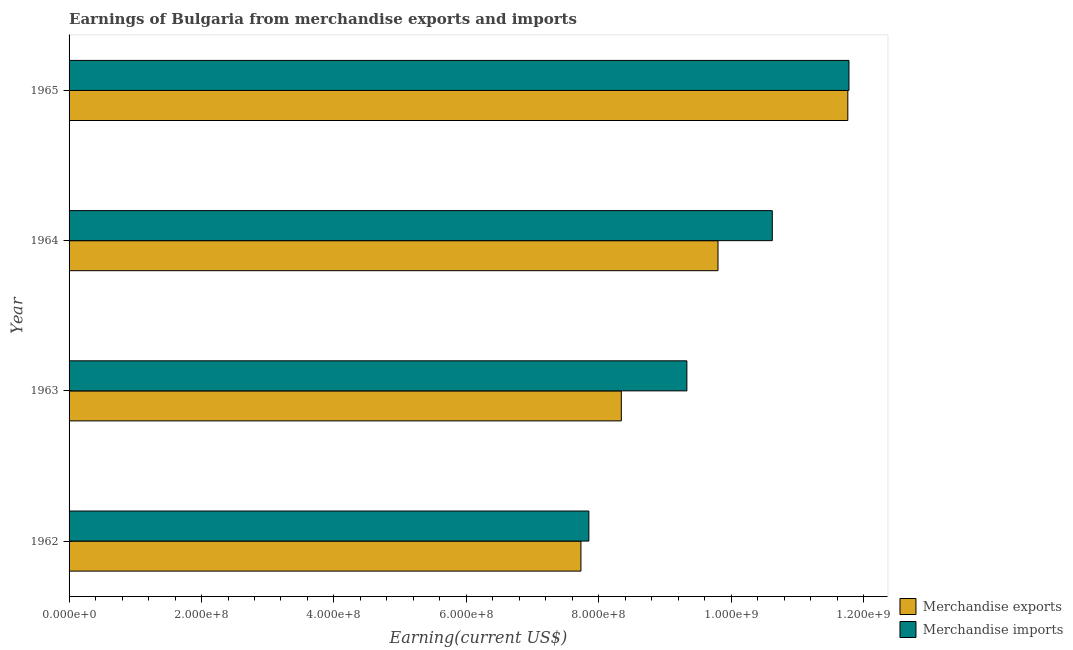How many different coloured bars are there?
Make the answer very short. 2. How many groups of bars are there?
Ensure brevity in your answer.  4. Are the number of bars per tick equal to the number of legend labels?
Your answer should be very brief. Yes. How many bars are there on the 2nd tick from the bottom?
Provide a succinct answer. 2. What is the earnings from merchandise imports in 1965?
Your answer should be very brief. 1.18e+09. Across all years, what is the maximum earnings from merchandise imports?
Give a very brief answer. 1.18e+09. Across all years, what is the minimum earnings from merchandise exports?
Offer a terse response. 7.73e+08. In which year was the earnings from merchandise imports maximum?
Ensure brevity in your answer.  1965. In which year was the earnings from merchandise imports minimum?
Your response must be concise. 1962. What is the total earnings from merchandise exports in the graph?
Ensure brevity in your answer.  3.76e+09. What is the difference between the earnings from merchandise exports in 1962 and that in 1963?
Keep it short and to the point. -6.10e+07. What is the difference between the earnings from merchandise imports in 1964 and the earnings from merchandise exports in 1963?
Ensure brevity in your answer.  2.28e+08. What is the average earnings from merchandise exports per year?
Make the answer very short. 9.41e+08. In the year 1965, what is the difference between the earnings from merchandise imports and earnings from merchandise exports?
Make the answer very short. 1.71e+06. What is the ratio of the earnings from merchandise exports in 1962 to that in 1963?
Offer a terse response. 0.93. Is the difference between the earnings from merchandise imports in 1962 and 1963 greater than the difference between the earnings from merchandise exports in 1962 and 1963?
Keep it short and to the point. No. What is the difference between the highest and the second highest earnings from merchandise exports?
Make the answer very short. 1.96e+08. What is the difference between the highest and the lowest earnings from merchandise exports?
Ensure brevity in your answer.  4.03e+08. In how many years, is the earnings from merchandise exports greater than the average earnings from merchandise exports taken over all years?
Give a very brief answer. 2. What does the 1st bar from the bottom in 1964 represents?
Give a very brief answer. Merchandise exports. How many bars are there?
Offer a terse response. 8. Are all the bars in the graph horizontal?
Give a very brief answer. Yes. How many years are there in the graph?
Offer a terse response. 4. Does the graph contain any zero values?
Your answer should be compact. No. Where does the legend appear in the graph?
Your response must be concise. Bottom right. How many legend labels are there?
Provide a short and direct response. 2. What is the title of the graph?
Ensure brevity in your answer.  Earnings of Bulgaria from merchandise exports and imports. Does "Researchers" appear as one of the legend labels in the graph?
Your answer should be compact. No. What is the label or title of the X-axis?
Your answer should be compact. Earning(current US$). What is the Earning(current US$) of Merchandise exports in 1962?
Offer a very short reply. 7.73e+08. What is the Earning(current US$) in Merchandise imports in 1962?
Ensure brevity in your answer.  7.85e+08. What is the Earning(current US$) in Merchandise exports in 1963?
Ensure brevity in your answer.  8.34e+08. What is the Earning(current US$) of Merchandise imports in 1963?
Make the answer very short. 9.33e+08. What is the Earning(current US$) of Merchandise exports in 1964?
Provide a short and direct response. 9.80e+08. What is the Earning(current US$) in Merchandise imports in 1964?
Give a very brief answer. 1.06e+09. What is the Earning(current US$) of Merchandise exports in 1965?
Your answer should be compact. 1.18e+09. What is the Earning(current US$) of Merchandise imports in 1965?
Provide a short and direct response. 1.18e+09. Across all years, what is the maximum Earning(current US$) in Merchandise exports?
Keep it short and to the point. 1.18e+09. Across all years, what is the maximum Earning(current US$) in Merchandise imports?
Make the answer very short. 1.18e+09. Across all years, what is the minimum Earning(current US$) of Merchandise exports?
Offer a very short reply. 7.73e+08. Across all years, what is the minimum Earning(current US$) of Merchandise imports?
Ensure brevity in your answer.  7.85e+08. What is the total Earning(current US$) in Merchandise exports in the graph?
Your response must be concise. 3.76e+09. What is the total Earning(current US$) in Merchandise imports in the graph?
Your answer should be very brief. 3.96e+09. What is the difference between the Earning(current US$) in Merchandise exports in 1962 and that in 1963?
Keep it short and to the point. -6.10e+07. What is the difference between the Earning(current US$) of Merchandise imports in 1962 and that in 1963?
Keep it short and to the point. -1.48e+08. What is the difference between the Earning(current US$) in Merchandise exports in 1962 and that in 1964?
Your response must be concise. -2.07e+08. What is the difference between the Earning(current US$) in Merchandise imports in 1962 and that in 1964?
Your answer should be compact. -2.77e+08. What is the difference between the Earning(current US$) of Merchandise exports in 1962 and that in 1965?
Ensure brevity in your answer.  -4.03e+08. What is the difference between the Earning(current US$) of Merchandise imports in 1962 and that in 1965?
Give a very brief answer. -3.93e+08. What is the difference between the Earning(current US$) of Merchandise exports in 1963 and that in 1964?
Keep it short and to the point. -1.46e+08. What is the difference between the Earning(current US$) in Merchandise imports in 1963 and that in 1964?
Offer a very short reply. -1.29e+08. What is the difference between the Earning(current US$) of Merchandise exports in 1963 and that in 1965?
Offer a terse response. -3.42e+08. What is the difference between the Earning(current US$) of Merchandise imports in 1963 and that in 1965?
Keep it short and to the point. -2.45e+08. What is the difference between the Earning(current US$) of Merchandise exports in 1964 and that in 1965?
Keep it short and to the point. -1.96e+08. What is the difference between the Earning(current US$) of Merchandise imports in 1964 and that in 1965?
Your response must be concise. -1.16e+08. What is the difference between the Earning(current US$) of Merchandise exports in 1962 and the Earning(current US$) of Merchandise imports in 1963?
Provide a short and direct response. -1.60e+08. What is the difference between the Earning(current US$) of Merchandise exports in 1962 and the Earning(current US$) of Merchandise imports in 1964?
Your answer should be very brief. -2.89e+08. What is the difference between the Earning(current US$) in Merchandise exports in 1962 and the Earning(current US$) in Merchandise imports in 1965?
Offer a terse response. -4.05e+08. What is the difference between the Earning(current US$) of Merchandise exports in 1963 and the Earning(current US$) of Merchandise imports in 1964?
Make the answer very short. -2.28e+08. What is the difference between the Earning(current US$) of Merchandise exports in 1963 and the Earning(current US$) of Merchandise imports in 1965?
Give a very brief answer. -3.44e+08. What is the difference between the Earning(current US$) in Merchandise exports in 1964 and the Earning(current US$) in Merchandise imports in 1965?
Give a very brief answer. -1.98e+08. What is the average Earning(current US$) in Merchandise exports per year?
Offer a terse response. 9.41e+08. What is the average Earning(current US$) of Merchandise imports per year?
Make the answer very short. 9.89e+08. In the year 1962, what is the difference between the Earning(current US$) of Merchandise exports and Earning(current US$) of Merchandise imports?
Your response must be concise. -1.20e+07. In the year 1963, what is the difference between the Earning(current US$) in Merchandise exports and Earning(current US$) in Merchandise imports?
Your response must be concise. -9.90e+07. In the year 1964, what is the difference between the Earning(current US$) in Merchandise exports and Earning(current US$) in Merchandise imports?
Provide a short and direct response. -8.20e+07. In the year 1965, what is the difference between the Earning(current US$) in Merchandise exports and Earning(current US$) in Merchandise imports?
Ensure brevity in your answer.  -1.71e+06. What is the ratio of the Earning(current US$) of Merchandise exports in 1962 to that in 1963?
Your response must be concise. 0.93. What is the ratio of the Earning(current US$) of Merchandise imports in 1962 to that in 1963?
Your answer should be very brief. 0.84. What is the ratio of the Earning(current US$) of Merchandise exports in 1962 to that in 1964?
Make the answer very short. 0.79. What is the ratio of the Earning(current US$) in Merchandise imports in 1962 to that in 1964?
Your response must be concise. 0.74. What is the ratio of the Earning(current US$) in Merchandise exports in 1962 to that in 1965?
Provide a short and direct response. 0.66. What is the ratio of the Earning(current US$) of Merchandise imports in 1962 to that in 1965?
Provide a succinct answer. 0.67. What is the ratio of the Earning(current US$) of Merchandise exports in 1963 to that in 1964?
Offer a terse response. 0.85. What is the ratio of the Earning(current US$) in Merchandise imports in 1963 to that in 1964?
Keep it short and to the point. 0.88. What is the ratio of the Earning(current US$) of Merchandise exports in 1963 to that in 1965?
Provide a short and direct response. 0.71. What is the ratio of the Earning(current US$) of Merchandise imports in 1963 to that in 1965?
Keep it short and to the point. 0.79. What is the ratio of the Earning(current US$) in Merchandise imports in 1964 to that in 1965?
Give a very brief answer. 0.9. What is the difference between the highest and the second highest Earning(current US$) of Merchandise exports?
Keep it short and to the point. 1.96e+08. What is the difference between the highest and the second highest Earning(current US$) in Merchandise imports?
Offer a very short reply. 1.16e+08. What is the difference between the highest and the lowest Earning(current US$) in Merchandise exports?
Offer a very short reply. 4.03e+08. What is the difference between the highest and the lowest Earning(current US$) of Merchandise imports?
Your answer should be compact. 3.93e+08. 